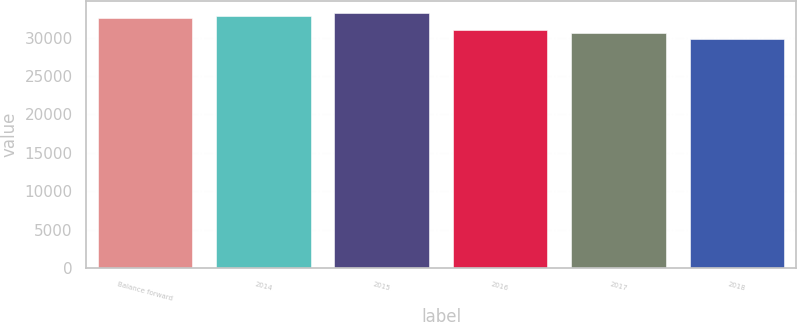Convert chart to OTSL. <chart><loc_0><loc_0><loc_500><loc_500><bar_chart><fcel>Balance forward<fcel>2014<fcel>2015<fcel>2016<fcel>2017<fcel>2018<nl><fcel>32494<fcel>32814.4<fcel>33134.8<fcel>30962.4<fcel>30642<fcel>29824<nl></chart> 